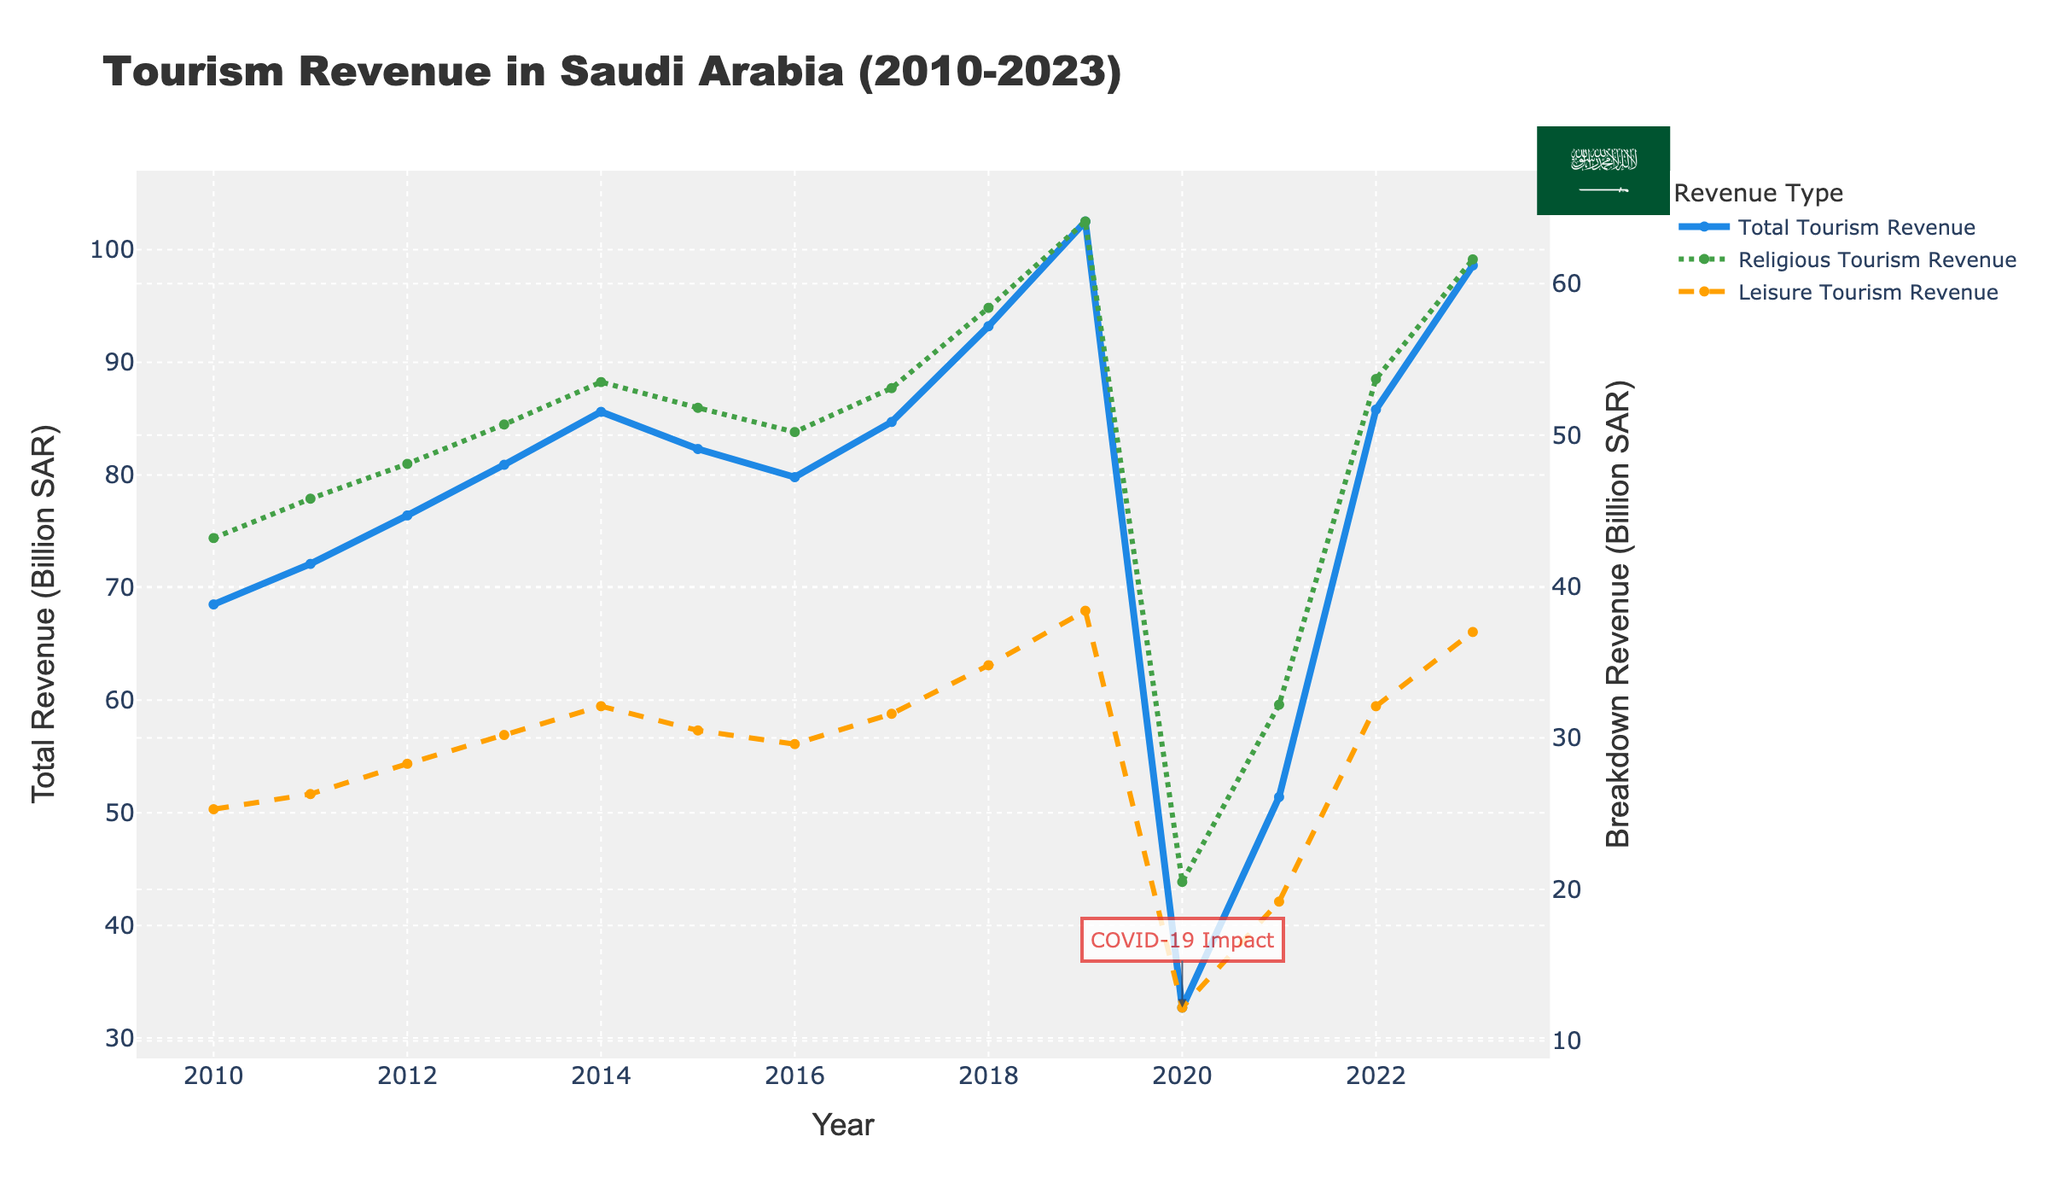Which year had the highest total tourism revenue? The highest total tourism revenue is represented by the highest point on the solid blue line.
Answer: 2019 How did the COVID-19 pandemic impact total tourism revenue in 2020? Comparing the total tourism revenue in 2020 with the years before and after, there is a significant drop from 102.5 billion SAR in 2019 to 32.7 billion SAR in 2020, as annotated on the chart.
Answer: There was a significant drop What is the difference in religious tourism revenue between the year with the highest revenue and 2020? The highest religious tourism revenue is in 2019 with 64.1 billion SAR. Subtracting the 2020 value of 20.5 billion SAR gives the difference. 64.1 - 20.5 = 43.6.
Answer: 43.6 billion SAR In which year did leisure tourism revenue start to significantly rise after a decline? Observing the dashed orange line, after a dip in 2015 and 2016, the leisure tourism revenue starts to rise significantly from 2017 onwards.
Answer: 2017 What is the total combined revenue from both religious and leisure tourism in 2023? Adding the religious tourism (61.6 billion SAR) and leisure tourism (37.0 billion SAR) revenues in 2023. 61.6 + 37.0 = 98.6.
Answer: 98.6 billion SAR How does the trend of religious tourism revenue compare to leisure tourism revenue over the years? Observing the lines, religious tourism revenue (green) consistently remains higher than leisure tourism revenue (orange) from 2010 to 2023, and both show similar trends with declines and rises, but the magnitude of change is greater in religious tourism.
Answer: Religious tourism revenue is consistently higher Which year marked the recovery of tourism revenue post-COVID-19 impact, and by how much did it increase from 2020 to that year? Examining the solid blue line, there's a noticeable increase in 2021 after the 2020 dip. The total tourism revenue increased from 32.7 billion SAR in 2020 to 51.4 billion SAR in 2021. 51.4 - 32.7 = 18.7.
Answer: 2021, increased by 18.7 billion SAR What is the trend of total tourism revenue from 2010 to 2019? Analyzing the solid blue line from 2010 to 2019, there's a consistent upward trend in total tourism revenue each year until 2019.
Answer: Upward trend In which year did Saudi Arabia experience its highest leisure tourism revenue, and what was the value? The highest point on the dashed orange line represents the highest leisure tourism revenue, which occurred in 2019 with a value of 38.4 billion SAR.
Answer: 2019, 38.4 billion SAR 